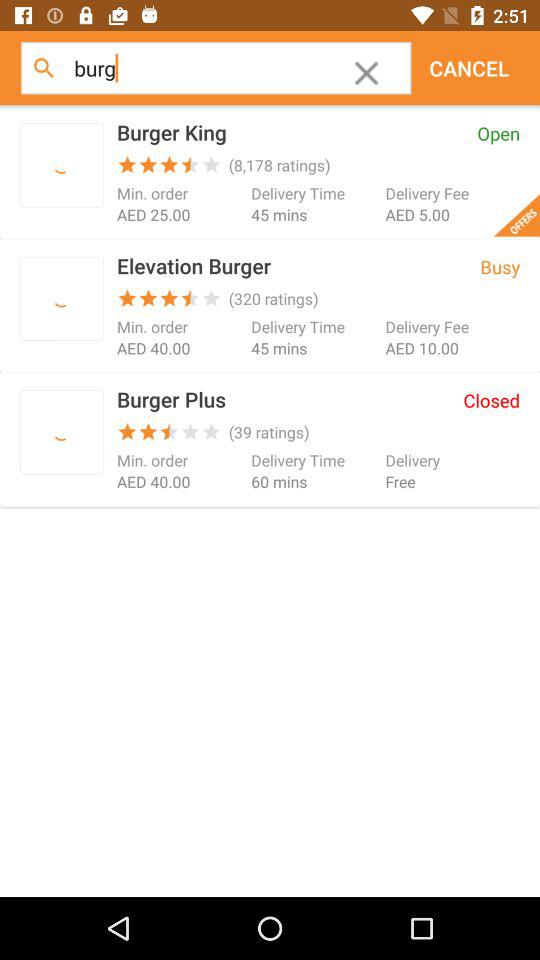In which store is the delivery free? The delivery is free in the "Burger Plus" store. 